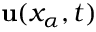Convert formula to latex. <formula><loc_0><loc_0><loc_500><loc_500>{ u } ( x _ { \alpha } , t )</formula> 